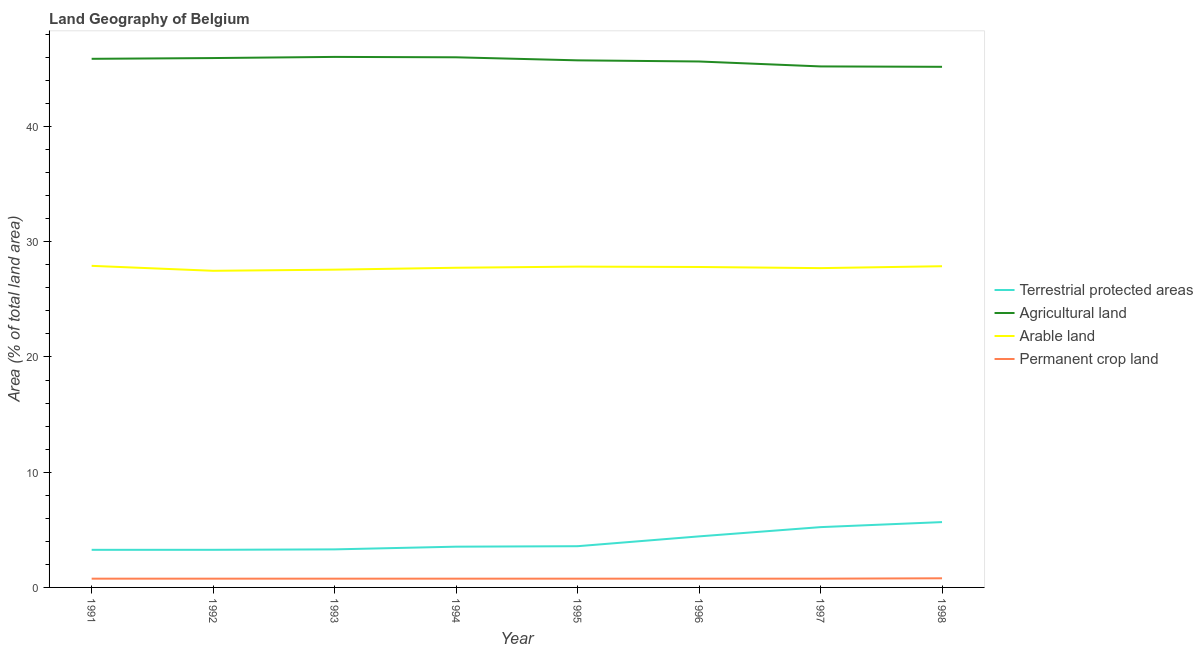How many different coloured lines are there?
Provide a succinct answer. 4. Does the line corresponding to percentage of land under terrestrial protection intersect with the line corresponding to percentage of area under arable land?
Make the answer very short. No. What is the percentage of land under terrestrial protection in 1993?
Your answer should be very brief. 3.3. Across all years, what is the maximum percentage of area under permanent crop land?
Provide a short and direct response. 0.79. Across all years, what is the minimum percentage of area under arable land?
Make the answer very short. 27.48. In which year was the percentage of area under arable land minimum?
Keep it short and to the point. 1992. What is the total percentage of area under arable land in the graph?
Keep it short and to the point. 221.93. What is the difference between the percentage of area under arable land in 1993 and that in 1994?
Offer a very short reply. -0.17. What is the difference between the percentage of area under agricultural land in 1996 and the percentage of land under terrestrial protection in 1995?
Give a very brief answer. 42.06. What is the average percentage of area under permanent crop land per year?
Offer a very short reply. 0.76. In the year 1993, what is the difference between the percentage of land under terrestrial protection and percentage of area under agricultural land?
Your answer should be compact. -42.74. In how many years, is the percentage of area under permanent crop land greater than 38 %?
Your answer should be very brief. 0. What is the ratio of the percentage of area under arable land in 1991 to that in 1994?
Offer a terse response. 1.01. Is the difference between the percentage of area under permanent crop land in 1992 and 1994 greater than the difference between the percentage of area under arable land in 1992 and 1994?
Keep it short and to the point. Yes. What is the difference between the highest and the second highest percentage of area under agricultural land?
Give a very brief answer. 0.03. What is the difference between the highest and the lowest percentage of area under arable land?
Ensure brevity in your answer.  0.43. Is the sum of the percentage of land under terrestrial protection in 1993 and 1997 greater than the maximum percentage of area under arable land across all years?
Provide a short and direct response. No. Is it the case that in every year, the sum of the percentage of area under agricultural land and percentage of area under permanent crop land is greater than the sum of percentage of land under terrestrial protection and percentage of area under arable land?
Offer a very short reply. No. Is it the case that in every year, the sum of the percentage of land under terrestrial protection and percentage of area under agricultural land is greater than the percentage of area under arable land?
Ensure brevity in your answer.  Yes. Is the percentage of land under terrestrial protection strictly less than the percentage of area under agricultural land over the years?
Your answer should be compact. Yes. What is the difference between two consecutive major ticks on the Y-axis?
Provide a short and direct response. 10. Are the values on the major ticks of Y-axis written in scientific E-notation?
Provide a short and direct response. No. Does the graph contain grids?
Your answer should be compact. No. Where does the legend appear in the graph?
Provide a short and direct response. Center right. How many legend labels are there?
Provide a short and direct response. 4. What is the title of the graph?
Make the answer very short. Land Geography of Belgium. Does "Australia" appear as one of the legend labels in the graph?
Offer a terse response. No. What is the label or title of the Y-axis?
Your answer should be compact. Area (% of total land area). What is the Area (% of total land area) of Terrestrial protected areas in 1991?
Offer a terse response. 3.26. What is the Area (% of total land area) of Agricultural land in 1991?
Offer a very short reply. 45.87. What is the Area (% of total land area) of Arable land in 1991?
Your response must be concise. 27.91. What is the Area (% of total land area) of Permanent crop land in 1991?
Offer a terse response. 0.76. What is the Area (% of total land area) in Terrestrial protected areas in 1992?
Give a very brief answer. 3.26. What is the Area (% of total land area) of Agricultural land in 1992?
Offer a very short reply. 45.94. What is the Area (% of total land area) of Arable land in 1992?
Ensure brevity in your answer.  27.48. What is the Area (% of total land area) of Permanent crop land in 1992?
Provide a short and direct response. 0.76. What is the Area (% of total land area) of Terrestrial protected areas in 1993?
Keep it short and to the point. 3.3. What is the Area (% of total land area) of Agricultural land in 1993?
Your answer should be compact. 46.04. What is the Area (% of total land area) in Arable land in 1993?
Keep it short and to the point. 27.58. What is the Area (% of total land area) of Permanent crop land in 1993?
Offer a terse response. 0.76. What is the Area (% of total land area) in Terrestrial protected areas in 1994?
Your response must be concise. 3.54. What is the Area (% of total land area) of Agricultural land in 1994?
Make the answer very short. 46. What is the Area (% of total land area) of Arable land in 1994?
Offer a very short reply. 27.74. What is the Area (% of total land area) of Permanent crop land in 1994?
Make the answer very short. 0.76. What is the Area (% of total land area) in Terrestrial protected areas in 1995?
Make the answer very short. 3.58. What is the Area (% of total land area) of Agricultural land in 1995?
Offer a very short reply. 45.74. What is the Area (% of total land area) in Arable land in 1995?
Your response must be concise. 27.84. What is the Area (% of total land area) of Permanent crop land in 1995?
Keep it short and to the point. 0.76. What is the Area (% of total land area) of Terrestrial protected areas in 1996?
Provide a succinct answer. 4.43. What is the Area (% of total land area) in Agricultural land in 1996?
Provide a short and direct response. 45.64. What is the Area (% of total land area) of Arable land in 1996?
Provide a short and direct response. 27.81. What is the Area (% of total land area) in Permanent crop land in 1996?
Your answer should be compact. 0.76. What is the Area (% of total land area) in Terrestrial protected areas in 1997?
Keep it short and to the point. 5.23. What is the Area (% of total land area) of Agricultural land in 1997?
Your response must be concise. 45.21. What is the Area (% of total land area) in Arable land in 1997?
Offer a very short reply. 27.71. What is the Area (% of total land area) in Permanent crop land in 1997?
Make the answer very short. 0.76. What is the Area (% of total land area) of Terrestrial protected areas in 1998?
Make the answer very short. 5.67. What is the Area (% of total land area) of Agricultural land in 1998?
Provide a succinct answer. 45.18. What is the Area (% of total land area) of Arable land in 1998?
Provide a succinct answer. 27.87. What is the Area (% of total land area) in Permanent crop land in 1998?
Keep it short and to the point. 0.79. Across all years, what is the maximum Area (% of total land area) in Terrestrial protected areas?
Give a very brief answer. 5.67. Across all years, what is the maximum Area (% of total land area) of Agricultural land?
Give a very brief answer. 46.04. Across all years, what is the maximum Area (% of total land area) of Arable land?
Make the answer very short. 27.91. Across all years, what is the maximum Area (% of total land area) of Permanent crop land?
Your answer should be very brief. 0.79. Across all years, what is the minimum Area (% of total land area) of Terrestrial protected areas?
Offer a terse response. 3.26. Across all years, what is the minimum Area (% of total land area) in Agricultural land?
Provide a succinct answer. 45.18. Across all years, what is the minimum Area (% of total land area) of Arable land?
Ensure brevity in your answer.  27.48. Across all years, what is the minimum Area (% of total land area) in Permanent crop land?
Your response must be concise. 0.76. What is the total Area (% of total land area) in Terrestrial protected areas in the graph?
Your response must be concise. 32.27. What is the total Area (% of total land area) in Agricultural land in the graph?
Your answer should be compact. 365.62. What is the total Area (% of total land area) of Arable land in the graph?
Offer a terse response. 221.93. What is the total Area (% of total land area) in Permanent crop land in the graph?
Ensure brevity in your answer.  6.11. What is the difference between the Area (% of total land area) in Terrestrial protected areas in 1991 and that in 1992?
Your answer should be very brief. -0. What is the difference between the Area (% of total land area) of Agricultural land in 1991 and that in 1992?
Provide a succinct answer. -0.07. What is the difference between the Area (% of total land area) of Arable land in 1991 and that in 1992?
Offer a terse response. 0.43. What is the difference between the Area (% of total land area) of Permanent crop land in 1991 and that in 1992?
Provide a succinct answer. 0. What is the difference between the Area (% of total land area) of Terrestrial protected areas in 1991 and that in 1993?
Ensure brevity in your answer.  -0.04. What is the difference between the Area (% of total land area) in Agricultural land in 1991 and that in 1993?
Your response must be concise. -0.17. What is the difference between the Area (% of total land area) of Arable land in 1991 and that in 1993?
Give a very brief answer. 0.33. What is the difference between the Area (% of total land area) of Terrestrial protected areas in 1991 and that in 1994?
Offer a very short reply. -0.27. What is the difference between the Area (% of total land area) of Agricultural land in 1991 and that in 1994?
Your answer should be compact. -0.13. What is the difference between the Area (% of total land area) in Arable land in 1991 and that in 1994?
Make the answer very short. 0.17. What is the difference between the Area (% of total land area) in Permanent crop land in 1991 and that in 1994?
Offer a very short reply. 0. What is the difference between the Area (% of total land area) of Terrestrial protected areas in 1991 and that in 1995?
Provide a succinct answer. -0.31. What is the difference between the Area (% of total land area) in Agricultural land in 1991 and that in 1995?
Your answer should be compact. 0.13. What is the difference between the Area (% of total land area) in Arable land in 1991 and that in 1995?
Ensure brevity in your answer.  0.07. What is the difference between the Area (% of total land area) of Permanent crop land in 1991 and that in 1995?
Keep it short and to the point. 0. What is the difference between the Area (% of total land area) of Terrestrial protected areas in 1991 and that in 1996?
Keep it short and to the point. -1.17. What is the difference between the Area (% of total land area) in Agricultural land in 1991 and that in 1996?
Ensure brevity in your answer.  0.23. What is the difference between the Area (% of total land area) in Arable land in 1991 and that in 1996?
Your answer should be very brief. 0.1. What is the difference between the Area (% of total land area) in Permanent crop land in 1991 and that in 1996?
Give a very brief answer. 0. What is the difference between the Area (% of total land area) of Terrestrial protected areas in 1991 and that in 1997?
Ensure brevity in your answer.  -1.97. What is the difference between the Area (% of total land area) of Agricultural land in 1991 and that in 1997?
Your answer should be compact. 0.66. What is the difference between the Area (% of total land area) of Arable land in 1991 and that in 1997?
Give a very brief answer. 0.2. What is the difference between the Area (% of total land area) in Terrestrial protected areas in 1991 and that in 1998?
Make the answer very short. -2.41. What is the difference between the Area (% of total land area) of Agricultural land in 1991 and that in 1998?
Provide a short and direct response. 0.69. What is the difference between the Area (% of total land area) of Arable land in 1991 and that in 1998?
Your answer should be compact. 0.03. What is the difference between the Area (% of total land area) in Permanent crop land in 1991 and that in 1998?
Give a very brief answer. -0.03. What is the difference between the Area (% of total land area) in Terrestrial protected areas in 1992 and that in 1993?
Keep it short and to the point. -0.04. What is the difference between the Area (% of total land area) in Agricultural land in 1992 and that in 1993?
Provide a succinct answer. -0.1. What is the difference between the Area (% of total land area) of Arable land in 1992 and that in 1993?
Your response must be concise. -0.1. What is the difference between the Area (% of total land area) of Terrestrial protected areas in 1992 and that in 1994?
Offer a terse response. -0.27. What is the difference between the Area (% of total land area) in Agricultural land in 1992 and that in 1994?
Offer a terse response. -0.07. What is the difference between the Area (% of total land area) of Arable land in 1992 and that in 1994?
Your answer should be very brief. -0.26. What is the difference between the Area (% of total land area) in Terrestrial protected areas in 1992 and that in 1995?
Provide a succinct answer. -0.31. What is the difference between the Area (% of total land area) of Agricultural land in 1992 and that in 1995?
Make the answer very short. 0.2. What is the difference between the Area (% of total land area) in Arable land in 1992 and that in 1995?
Your answer should be compact. -0.36. What is the difference between the Area (% of total land area) of Permanent crop land in 1992 and that in 1995?
Ensure brevity in your answer.  0. What is the difference between the Area (% of total land area) in Terrestrial protected areas in 1992 and that in 1996?
Make the answer very short. -1.17. What is the difference between the Area (% of total land area) of Agricultural land in 1992 and that in 1996?
Offer a very short reply. 0.3. What is the difference between the Area (% of total land area) in Arable land in 1992 and that in 1996?
Your answer should be very brief. -0.33. What is the difference between the Area (% of total land area) of Terrestrial protected areas in 1992 and that in 1997?
Provide a succinct answer. -1.97. What is the difference between the Area (% of total land area) in Agricultural land in 1992 and that in 1997?
Keep it short and to the point. 0.73. What is the difference between the Area (% of total land area) of Arable land in 1992 and that in 1997?
Your answer should be compact. -0.23. What is the difference between the Area (% of total land area) of Permanent crop land in 1992 and that in 1997?
Keep it short and to the point. 0. What is the difference between the Area (% of total land area) in Terrestrial protected areas in 1992 and that in 1998?
Your response must be concise. -2.41. What is the difference between the Area (% of total land area) of Agricultural land in 1992 and that in 1998?
Offer a very short reply. 0.76. What is the difference between the Area (% of total land area) of Arable land in 1992 and that in 1998?
Your response must be concise. -0.4. What is the difference between the Area (% of total land area) of Permanent crop land in 1992 and that in 1998?
Give a very brief answer. -0.03. What is the difference between the Area (% of total land area) of Terrestrial protected areas in 1993 and that in 1994?
Make the answer very short. -0.24. What is the difference between the Area (% of total land area) of Agricultural land in 1993 and that in 1994?
Your answer should be very brief. 0.03. What is the difference between the Area (% of total land area) in Arable land in 1993 and that in 1994?
Keep it short and to the point. -0.17. What is the difference between the Area (% of total land area) of Terrestrial protected areas in 1993 and that in 1995?
Keep it short and to the point. -0.28. What is the difference between the Area (% of total land area) in Agricultural land in 1993 and that in 1995?
Offer a terse response. 0.3. What is the difference between the Area (% of total land area) in Arable land in 1993 and that in 1995?
Give a very brief answer. -0.26. What is the difference between the Area (% of total land area) of Permanent crop land in 1993 and that in 1995?
Your answer should be very brief. 0. What is the difference between the Area (% of total land area) in Terrestrial protected areas in 1993 and that in 1996?
Offer a terse response. -1.13. What is the difference between the Area (% of total land area) in Agricultural land in 1993 and that in 1996?
Offer a very short reply. 0.4. What is the difference between the Area (% of total land area) in Arable land in 1993 and that in 1996?
Offer a terse response. -0.23. What is the difference between the Area (% of total land area) of Terrestrial protected areas in 1993 and that in 1997?
Your response must be concise. -1.93. What is the difference between the Area (% of total land area) in Agricultural land in 1993 and that in 1997?
Give a very brief answer. 0.83. What is the difference between the Area (% of total land area) in Arable land in 1993 and that in 1997?
Make the answer very short. -0.13. What is the difference between the Area (% of total land area) of Permanent crop land in 1993 and that in 1997?
Your response must be concise. 0. What is the difference between the Area (% of total land area) in Terrestrial protected areas in 1993 and that in 1998?
Your answer should be very brief. -2.37. What is the difference between the Area (% of total land area) in Agricultural land in 1993 and that in 1998?
Your answer should be compact. 0.86. What is the difference between the Area (% of total land area) in Arable land in 1993 and that in 1998?
Your answer should be compact. -0.3. What is the difference between the Area (% of total land area) in Permanent crop land in 1993 and that in 1998?
Provide a succinct answer. -0.03. What is the difference between the Area (% of total land area) of Terrestrial protected areas in 1994 and that in 1995?
Make the answer very short. -0.04. What is the difference between the Area (% of total land area) in Agricultural land in 1994 and that in 1995?
Offer a terse response. 0.26. What is the difference between the Area (% of total land area) of Arable land in 1994 and that in 1995?
Your answer should be compact. -0.1. What is the difference between the Area (% of total land area) in Permanent crop land in 1994 and that in 1995?
Provide a short and direct response. 0. What is the difference between the Area (% of total land area) of Terrestrial protected areas in 1994 and that in 1996?
Keep it short and to the point. -0.89. What is the difference between the Area (% of total land area) in Agricultural land in 1994 and that in 1996?
Keep it short and to the point. 0.36. What is the difference between the Area (% of total land area) of Arable land in 1994 and that in 1996?
Offer a very short reply. -0.07. What is the difference between the Area (% of total land area) of Permanent crop land in 1994 and that in 1996?
Provide a short and direct response. 0. What is the difference between the Area (% of total land area) of Terrestrial protected areas in 1994 and that in 1997?
Make the answer very short. -1.7. What is the difference between the Area (% of total land area) of Agricultural land in 1994 and that in 1997?
Provide a succinct answer. 0.79. What is the difference between the Area (% of total land area) of Arable land in 1994 and that in 1997?
Ensure brevity in your answer.  0.03. What is the difference between the Area (% of total land area) of Permanent crop land in 1994 and that in 1997?
Your response must be concise. 0. What is the difference between the Area (% of total land area) of Terrestrial protected areas in 1994 and that in 1998?
Ensure brevity in your answer.  -2.13. What is the difference between the Area (% of total land area) in Agricultural land in 1994 and that in 1998?
Ensure brevity in your answer.  0.83. What is the difference between the Area (% of total land area) in Arable land in 1994 and that in 1998?
Make the answer very short. -0.13. What is the difference between the Area (% of total land area) of Permanent crop land in 1994 and that in 1998?
Give a very brief answer. -0.03. What is the difference between the Area (% of total land area) of Terrestrial protected areas in 1995 and that in 1996?
Offer a terse response. -0.85. What is the difference between the Area (% of total land area) of Agricultural land in 1995 and that in 1996?
Provide a succinct answer. 0.1. What is the difference between the Area (% of total land area) of Arable land in 1995 and that in 1996?
Ensure brevity in your answer.  0.03. What is the difference between the Area (% of total land area) in Permanent crop land in 1995 and that in 1996?
Provide a succinct answer. 0. What is the difference between the Area (% of total land area) in Terrestrial protected areas in 1995 and that in 1997?
Your response must be concise. -1.66. What is the difference between the Area (% of total land area) in Agricultural land in 1995 and that in 1997?
Ensure brevity in your answer.  0.53. What is the difference between the Area (% of total land area) of Arable land in 1995 and that in 1997?
Make the answer very short. 0.13. What is the difference between the Area (% of total land area) in Permanent crop land in 1995 and that in 1997?
Ensure brevity in your answer.  0. What is the difference between the Area (% of total land area) in Terrestrial protected areas in 1995 and that in 1998?
Make the answer very short. -2.09. What is the difference between the Area (% of total land area) of Agricultural land in 1995 and that in 1998?
Offer a very short reply. 0.56. What is the difference between the Area (% of total land area) in Arable land in 1995 and that in 1998?
Your answer should be very brief. -0.03. What is the difference between the Area (% of total land area) of Permanent crop land in 1995 and that in 1998?
Your answer should be compact. -0.03. What is the difference between the Area (% of total land area) of Terrestrial protected areas in 1996 and that in 1997?
Offer a terse response. -0.8. What is the difference between the Area (% of total land area) of Agricultural land in 1996 and that in 1997?
Your answer should be compact. 0.43. What is the difference between the Area (% of total land area) in Arable land in 1996 and that in 1997?
Keep it short and to the point. 0.1. What is the difference between the Area (% of total land area) of Permanent crop land in 1996 and that in 1997?
Give a very brief answer. 0. What is the difference between the Area (% of total land area) of Terrestrial protected areas in 1996 and that in 1998?
Your response must be concise. -1.24. What is the difference between the Area (% of total land area) of Agricultural land in 1996 and that in 1998?
Your response must be concise. 0.46. What is the difference between the Area (% of total land area) of Arable land in 1996 and that in 1998?
Offer a very short reply. -0.07. What is the difference between the Area (% of total land area) in Permanent crop land in 1996 and that in 1998?
Offer a very short reply. -0.03. What is the difference between the Area (% of total land area) in Terrestrial protected areas in 1997 and that in 1998?
Your answer should be compact. -0.44. What is the difference between the Area (% of total land area) in Agricultural land in 1997 and that in 1998?
Your response must be concise. 0.03. What is the difference between the Area (% of total land area) of Arable land in 1997 and that in 1998?
Ensure brevity in your answer.  -0.17. What is the difference between the Area (% of total land area) in Permanent crop land in 1997 and that in 1998?
Your answer should be very brief. -0.03. What is the difference between the Area (% of total land area) of Terrestrial protected areas in 1991 and the Area (% of total land area) of Agricultural land in 1992?
Provide a succinct answer. -42.68. What is the difference between the Area (% of total land area) in Terrestrial protected areas in 1991 and the Area (% of total land area) in Arable land in 1992?
Your response must be concise. -24.21. What is the difference between the Area (% of total land area) of Terrestrial protected areas in 1991 and the Area (% of total land area) of Permanent crop land in 1992?
Your answer should be compact. 2.5. What is the difference between the Area (% of total land area) in Agricultural land in 1991 and the Area (% of total land area) in Arable land in 1992?
Provide a succinct answer. 18.39. What is the difference between the Area (% of total land area) in Agricultural land in 1991 and the Area (% of total land area) in Permanent crop land in 1992?
Keep it short and to the point. 45.11. What is the difference between the Area (% of total land area) of Arable land in 1991 and the Area (% of total land area) of Permanent crop land in 1992?
Your response must be concise. 27.15. What is the difference between the Area (% of total land area) in Terrestrial protected areas in 1991 and the Area (% of total land area) in Agricultural land in 1993?
Your answer should be very brief. -42.77. What is the difference between the Area (% of total land area) of Terrestrial protected areas in 1991 and the Area (% of total land area) of Arable land in 1993?
Make the answer very short. -24.31. What is the difference between the Area (% of total land area) of Terrestrial protected areas in 1991 and the Area (% of total land area) of Permanent crop land in 1993?
Provide a succinct answer. 2.5. What is the difference between the Area (% of total land area) in Agricultural land in 1991 and the Area (% of total land area) in Arable land in 1993?
Your response must be concise. 18.3. What is the difference between the Area (% of total land area) in Agricultural land in 1991 and the Area (% of total land area) in Permanent crop land in 1993?
Ensure brevity in your answer.  45.11. What is the difference between the Area (% of total land area) of Arable land in 1991 and the Area (% of total land area) of Permanent crop land in 1993?
Provide a short and direct response. 27.15. What is the difference between the Area (% of total land area) of Terrestrial protected areas in 1991 and the Area (% of total land area) of Agricultural land in 1994?
Provide a short and direct response. -42.74. What is the difference between the Area (% of total land area) in Terrestrial protected areas in 1991 and the Area (% of total land area) in Arable land in 1994?
Keep it short and to the point. -24.48. What is the difference between the Area (% of total land area) in Terrestrial protected areas in 1991 and the Area (% of total land area) in Permanent crop land in 1994?
Provide a short and direct response. 2.5. What is the difference between the Area (% of total land area) in Agricultural land in 1991 and the Area (% of total land area) in Arable land in 1994?
Your answer should be very brief. 18.13. What is the difference between the Area (% of total land area) in Agricultural land in 1991 and the Area (% of total land area) in Permanent crop land in 1994?
Offer a terse response. 45.11. What is the difference between the Area (% of total land area) in Arable land in 1991 and the Area (% of total land area) in Permanent crop land in 1994?
Provide a short and direct response. 27.15. What is the difference between the Area (% of total land area) in Terrestrial protected areas in 1991 and the Area (% of total land area) in Agricultural land in 1995?
Provide a succinct answer. -42.48. What is the difference between the Area (% of total land area) of Terrestrial protected areas in 1991 and the Area (% of total land area) of Arable land in 1995?
Offer a terse response. -24.58. What is the difference between the Area (% of total land area) of Terrestrial protected areas in 1991 and the Area (% of total land area) of Permanent crop land in 1995?
Your answer should be very brief. 2.5. What is the difference between the Area (% of total land area) in Agricultural land in 1991 and the Area (% of total land area) in Arable land in 1995?
Provide a short and direct response. 18.03. What is the difference between the Area (% of total land area) in Agricultural land in 1991 and the Area (% of total land area) in Permanent crop land in 1995?
Offer a terse response. 45.11. What is the difference between the Area (% of total land area) of Arable land in 1991 and the Area (% of total land area) of Permanent crop land in 1995?
Your response must be concise. 27.15. What is the difference between the Area (% of total land area) in Terrestrial protected areas in 1991 and the Area (% of total land area) in Agricultural land in 1996?
Keep it short and to the point. -42.38. What is the difference between the Area (% of total land area) of Terrestrial protected areas in 1991 and the Area (% of total land area) of Arable land in 1996?
Give a very brief answer. -24.54. What is the difference between the Area (% of total land area) in Terrestrial protected areas in 1991 and the Area (% of total land area) in Permanent crop land in 1996?
Offer a terse response. 2.5. What is the difference between the Area (% of total land area) in Agricultural land in 1991 and the Area (% of total land area) in Arable land in 1996?
Your answer should be very brief. 18.06. What is the difference between the Area (% of total land area) of Agricultural land in 1991 and the Area (% of total land area) of Permanent crop land in 1996?
Give a very brief answer. 45.11. What is the difference between the Area (% of total land area) of Arable land in 1991 and the Area (% of total land area) of Permanent crop land in 1996?
Your answer should be very brief. 27.15. What is the difference between the Area (% of total land area) of Terrestrial protected areas in 1991 and the Area (% of total land area) of Agricultural land in 1997?
Give a very brief answer. -41.95. What is the difference between the Area (% of total land area) in Terrestrial protected areas in 1991 and the Area (% of total land area) in Arable land in 1997?
Ensure brevity in your answer.  -24.45. What is the difference between the Area (% of total land area) in Terrestrial protected areas in 1991 and the Area (% of total land area) in Permanent crop land in 1997?
Keep it short and to the point. 2.5. What is the difference between the Area (% of total land area) of Agricultural land in 1991 and the Area (% of total land area) of Arable land in 1997?
Provide a succinct answer. 18.16. What is the difference between the Area (% of total land area) of Agricultural land in 1991 and the Area (% of total land area) of Permanent crop land in 1997?
Your answer should be very brief. 45.11. What is the difference between the Area (% of total land area) in Arable land in 1991 and the Area (% of total land area) in Permanent crop land in 1997?
Offer a very short reply. 27.15. What is the difference between the Area (% of total land area) in Terrestrial protected areas in 1991 and the Area (% of total land area) in Agricultural land in 1998?
Your answer should be very brief. -41.92. What is the difference between the Area (% of total land area) of Terrestrial protected areas in 1991 and the Area (% of total land area) of Arable land in 1998?
Keep it short and to the point. -24.61. What is the difference between the Area (% of total land area) of Terrestrial protected areas in 1991 and the Area (% of total land area) of Permanent crop land in 1998?
Your answer should be very brief. 2.47. What is the difference between the Area (% of total land area) of Agricultural land in 1991 and the Area (% of total land area) of Arable land in 1998?
Ensure brevity in your answer.  18. What is the difference between the Area (% of total land area) of Agricultural land in 1991 and the Area (% of total land area) of Permanent crop land in 1998?
Provide a short and direct response. 45.08. What is the difference between the Area (% of total land area) of Arable land in 1991 and the Area (% of total land area) of Permanent crop land in 1998?
Provide a short and direct response. 27.11. What is the difference between the Area (% of total land area) in Terrestrial protected areas in 1992 and the Area (% of total land area) in Agricultural land in 1993?
Your response must be concise. -42.77. What is the difference between the Area (% of total land area) in Terrestrial protected areas in 1992 and the Area (% of total land area) in Arable land in 1993?
Ensure brevity in your answer.  -24.31. What is the difference between the Area (% of total land area) of Terrestrial protected areas in 1992 and the Area (% of total land area) of Permanent crop land in 1993?
Offer a very short reply. 2.5. What is the difference between the Area (% of total land area) of Agricultural land in 1992 and the Area (% of total land area) of Arable land in 1993?
Ensure brevity in your answer.  18.36. What is the difference between the Area (% of total land area) in Agricultural land in 1992 and the Area (% of total land area) in Permanent crop land in 1993?
Give a very brief answer. 45.18. What is the difference between the Area (% of total land area) in Arable land in 1992 and the Area (% of total land area) in Permanent crop land in 1993?
Ensure brevity in your answer.  26.72. What is the difference between the Area (% of total land area) of Terrestrial protected areas in 1992 and the Area (% of total land area) of Agricultural land in 1994?
Provide a short and direct response. -42.74. What is the difference between the Area (% of total land area) in Terrestrial protected areas in 1992 and the Area (% of total land area) in Arable land in 1994?
Give a very brief answer. -24.48. What is the difference between the Area (% of total land area) in Terrestrial protected areas in 1992 and the Area (% of total land area) in Permanent crop land in 1994?
Your answer should be compact. 2.5. What is the difference between the Area (% of total land area) in Agricultural land in 1992 and the Area (% of total land area) in Arable land in 1994?
Your answer should be very brief. 18.2. What is the difference between the Area (% of total land area) in Agricultural land in 1992 and the Area (% of total land area) in Permanent crop land in 1994?
Provide a short and direct response. 45.18. What is the difference between the Area (% of total land area) in Arable land in 1992 and the Area (% of total land area) in Permanent crop land in 1994?
Keep it short and to the point. 26.72. What is the difference between the Area (% of total land area) in Terrestrial protected areas in 1992 and the Area (% of total land area) in Agricultural land in 1995?
Ensure brevity in your answer.  -42.48. What is the difference between the Area (% of total land area) in Terrestrial protected areas in 1992 and the Area (% of total land area) in Arable land in 1995?
Offer a terse response. -24.58. What is the difference between the Area (% of total land area) in Terrestrial protected areas in 1992 and the Area (% of total land area) in Permanent crop land in 1995?
Ensure brevity in your answer.  2.5. What is the difference between the Area (% of total land area) of Agricultural land in 1992 and the Area (% of total land area) of Arable land in 1995?
Offer a terse response. 18.1. What is the difference between the Area (% of total land area) in Agricultural land in 1992 and the Area (% of total land area) in Permanent crop land in 1995?
Make the answer very short. 45.18. What is the difference between the Area (% of total land area) of Arable land in 1992 and the Area (% of total land area) of Permanent crop land in 1995?
Provide a short and direct response. 26.72. What is the difference between the Area (% of total land area) in Terrestrial protected areas in 1992 and the Area (% of total land area) in Agricultural land in 1996?
Provide a short and direct response. -42.38. What is the difference between the Area (% of total land area) of Terrestrial protected areas in 1992 and the Area (% of total land area) of Arable land in 1996?
Provide a succinct answer. -24.54. What is the difference between the Area (% of total land area) of Terrestrial protected areas in 1992 and the Area (% of total land area) of Permanent crop land in 1996?
Your answer should be compact. 2.5. What is the difference between the Area (% of total land area) of Agricultural land in 1992 and the Area (% of total land area) of Arable land in 1996?
Provide a succinct answer. 18.13. What is the difference between the Area (% of total land area) in Agricultural land in 1992 and the Area (% of total land area) in Permanent crop land in 1996?
Provide a succinct answer. 45.18. What is the difference between the Area (% of total land area) of Arable land in 1992 and the Area (% of total land area) of Permanent crop land in 1996?
Your response must be concise. 26.72. What is the difference between the Area (% of total land area) in Terrestrial protected areas in 1992 and the Area (% of total land area) in Agricultural land in 1997?
Give a very brief answer. -41.95. What is the difference between the Area (% of total land area) of Terrestrial protected areas in 1992 and the Area (% of total land area) of Arable land in 1997?
Offer a terse response. -24.44. What is the difference between the Area (% of total land area) of Terrestrial protected areas in 1992 and the Area (% of total land area) of Permanent crop land in 1997?
Offer a very short reply. 2.5. What is the difference between the Area (% of total land area) of Agricultural land in 1992 and the Area (% of total land area) of Arable land in 1997?
Make the answer very short. 18.23. What is the difference between the Area (% of total land area) of Agricultural land in 1992 and the Area (% of total land area) of Permanent crop land in 1997?
Offer a terse response. 45.18. What is the difference between the Area (% of total land area) in Arable land in 1992 and the Area (% of total land area) in Permanent crop land in 1997?
Make the answer very short. 26.72. What is the difference between the Area (% of total land area) in Terrestrial protected areas in 1992 and the Area (% of total land area) in Agricultural land in 1998?
Your answer should be very brief. -41.91. What is the difference between the Area (% of total land area) in Terrestrial protected areas in 1992 and the Area (% of total land area) in Arable land in 1998?
Make the answer very short. -24.61. What is the difference between the Area (% of total land area) in Terrestrial protected areas in 1992 and the Area (% of total land area) in Permanent crop land in 1998?
Offer a very short reply. 2.47. What is the difference between the Area (% of total land area) in Agricultural land in 1992 and the Area (% of total land area) in Arable land in 1998?
Your response must be concise. 18.06. What is the difference between the Area (% of total land area) of Agricultural land in 1992 and the Area (% of total land area) of Permanent crop land in 1998?
Make the answer very short. 45.15. What is the difference between the Area (% of total land area) in Arable land in 1992 and the Area (% of total land area) in Permanent crop land in 1998?
Make the answer very short. 26.68. What is the difference between the Area (% of total land area) of Terrestrial protected areas in 1993 and the Area (% of total land area) of Agricultural land in 1994?
Give a very brief answer. -42.7. What is the difference between the Area (% of total land area) of Terrestrial protected areas in 1993 and the Area (% of total land area) of Arable land in 1994?
Your answer should be very brief. -24.44. What is the difference between the Area (% of total land area) in Terrestrial protected areas in 1993 and the Area (% of total land area) in Permanent crop land in 1994?
Make the answer very short. 2.54. What is the difference between the Area (% of total land area) of Agricultural land in 1993 and the Area (% of total land area) of Arable land in 1994?
Make the answer very short. 18.3. What is the difference between the Area (% of total land area) in Agricultural land in 1993 and the Area (% of total land area) in Permanent crop land in 1994?
Offer a terse response. 45.28. What is the difference between the Area (% of total land area) in Arable land in 1993 and the Area (% of total land area) in Permanent crop land in 1994?
Provide a succinct answer. 26.82. What is the difference between the Area (% of total land area) in Terrestrial protected areas in 1993 and the Area (% of total land area) in Agricultural land in 1995?
Give a very brief answer. -42.44. What is the difference between the Area (% of total land area) in Terrestrial protected areas in 1993 and the Area (% of total land area) in Arable land in 1995?
Provide a short and direct response. -24.54. What is the difference between the Area (% of total land area) of Terrestrial protected areas in 1993 and the Area (% of total land area) of Permanent crop land in 1995?
Your response must be concise. 2.54. What is the difference between the Area (% of total land area) of Agricultural land in 1993 and the Area (% of total land area) of Arable land in 1995?
Your response must be concise. 18.2. What is the difference between the Area (% of total land area) in Agricultural land in 1993 and the Area (% of total land area) in Permanent crop land in 1995?
Your answer should be compact. 45.28. What is the difference between the Area (% of total land area) of Arable land in 1993 and the Area (% of total land area) of Permanent crop land in 1995?
Your answer should be very brief. 26.82. What is the difference between the Area (% of total land area) in Terrestrial protected areas in 1993 and the Area (% of total land area) in Agricultural land in 1996?
Keep it short and to the point. -42.34. What is the difference between the Area (% of total land area) in Terrestrial protected areas in 1993 and the Area (% of total land area) in Arable land in 1996?
Provide a short and direct response. -24.51. What is the difference between the Area (% of total land area) in Terrestrial protected areas in 1993 and the Area (% of total land area) in Permanent crop land in 1996?
Keep it short and to the point. 2.54. What is the difference between the Area (% of total land area) in Agricultural land in 1993 and the Area (% of total land area) in Arable land in 1996?
Your answer should be very brief. 18.23. What is the difference between the Area (% of total land area) in Agricultural land in 1993 and the Area (% of total land area) in Permanent crop land in 1996?
Your answer should be very brief. 45.28. What is the difference between the Area (% of total land area) in Arable land in 1993 and the Area (% of total land area) in Permanent crop land in 1996?
Give a very brief answer. 26.82. What is the difference between the Area (% of total land area) of Terrestrial protected areas in 1993 and the Area (% of total land area) of Agricultural land in 1997?
Ensure brevity in your answer.  -41.91. What is the difference between the Area (% of total land area) of Terrestrial protected areas in 1993 and the Area (% of total land area) of Arable land in 1997?
Provide a short and direct response. -24.41. What is the difference between the Area (% of total land area) in Terrestrial protected areas in 1993 and the Area (% of total land area) in Permanent crop land in 1997?
Ensure brevity in your answer.  2.54. What is the difference between the Area (% of total land area) of Agricultural land in 1993 and the Area (% of total land area) of Arable land in 1997?
Keep it short and to the point. 18.33. What is the difference between the Area (% of total land area) in Agricultural land in 1993 and the Area (% of total land area) in Permanent crop land in 1997?
Your answer should be very brief. 45.28. What is the difference between the Area (% of total land area) of Arable land in 1993 and the Area (% of total land area) of Permanent crop land in 1997?
Offer a very short reply. 26.82. What is the difference between the Area (% of total land area) in Terrestrial protected areas in 1993 and the Area (% of total land area) in Agricultural land in 1998?
Keep it short and to the point. -41.88. What is the difference between the Area (% of total land area) of Terrestrial protected areas in 1993 and the Area (% of total land area) of Arable land in 1998?
Offer a terse response. -24.57. What is the difference between the Area (% of total land area) in Terrestrial protected areas in 1993 and the Area (% of total land area) in Permanent crop land in 1998?
Provide a succinct answer. 2.51. What is the difference between the Area (% of total land area) of Agricultural land in 1993 and the Area (% of total land area) of Arable land in 1998?
Your response must be concise. 18.16. What is the difference between the Area (% of total land area) of Agricultural land in 1993 and the Area (% of total land area) of Permanent crop land in 1998?
Provide a short and direct response. 45.24. What is the difference between the Area (% of total land area) in Arable land in 1993 and the Area (% of total land area) in Permanent crop land in 1998?
Your answer should be very brief. 26.78. What is the difference between the Area (% of total land area) in Terrestrial protected areas in 1994 and the Area (% of total land area) in Agricultural land in 1995?
Provide a short and direct response. -42.2. What is the difference between the Area (% of total land area) in Terrestrial protected areas in 1994 and the Area (% of total land area) in Arable land in 1995?
Give a very brief answer. -24.3. What is the difference between the Area (% of total land area) in Terrestrial protected areas in 1994 and the Area (% of total land area) in Permanent crop land in 1995?
Ensure brevity in your answer.  2.78. What is the difference between the Area (% of total land area) in Agricultural land in 1994 and the Area (% of total land area) in Arable land in 1995?
Your answer should be compact. 18.16. What is the difference between the Area (% of total land area) of Agricultural land in 1994 and the Area (% of total land area) of Permanent crop land in 1995?
Provide a short and direct response. 45.24. What is the difference between the Area (% of total land area) in Arable land in 1994 and the Area (% of total land area) in Permanent crop land in 1995?
Keep it short and to the point. 26.98. What is the difference between the Area (% of total land area) in Terrestrial protected areas in 1994 and the Area (% of total land area) in Agricultural land in 1996?
Keep it short and to the point. -42.1. What is the difference between the Area (% of total land area) in Terrestrial protected areas in 1994 and the Area (% of total land area) in Arable land in 1996?
Your response must be concise. -24.27. What is the difference between the Area (% of total land area) of Terrestrial protected areas in 1994 and the Area (% of total land area) of Permanent crop land in 1996?
Keep it short and to the point. 2.78. What is the difference between the Area (% of total land area) in Agricultural land in 1994 and the Area (% of total land area) in Arable land in 1996?
Your answer should be very brief. 18.2. What is the difference between the Area (% of total land area) in Agricultural land in 1994 and the Area (% of total land area) in Permanent crop land in 1996?
Provide a succinct answer. 45.24. What is the difference between the Area (% of total land area) of Arable land in 1994 and the Area (% of total land area) of Permanent crop land in 1996?
Give a very brief answer. 26.98. What is the difference between the Area (% of total land area) of Terrestrial protected areas in 1994 and the Area (% of total land area) of Agricultural land in 1997?
Ensure brevity in your answer.  -41.67. What is the difference between the Area (% of total land area) in Terrestrial protected areas in 1994 and the Area (% of total land area) in Arable land in 1997?
Offer a terse response. -24.17. What is the difference between the Area (% of total land area) in Terrestrial protected areas in 1994 and the Area (% of total land area) in Permanent crop land in 1997?
Offer a very short reply. 2.78. What is the difference between the Area (% of total land area) in Agricultural land in 1994 and the Area (% of total land area) in Arable land in 1997?
Ensure brevity in your answer.  18.3. What is the difference between the Area (% of total land area) of Agricultural land in 1994 and the Area (% of total land area) of Permanent crop land in 1997?
Offer a terse response. 45.24. What is the difference between the Area (% of total land area) of Arable land in 1994 and the Area (% of total land area) of Permanent crop land in 1997?
Offer a very short reply. 26.98. What is the difference between the Area (% of total land area) in Terrestrial protected areas in 1994 and the Area (% of total land area) in Agricultural land in 1998?
Offer a terse response. -41.64. What is the difference between the Area (% of total land area) of Terrestrial protected areas in 1994 and the Area (% of total land area) of Arable land in 1998?
Your answer should be very brief. -24.34. What is the difference between the Area (% of total land area) of Terrestrial protected areas in 1994 and the Area (% of total land area) of Permanent crop land in 1998?
Your answer should be very brief. 2.74. What is the difference between the Area (% of total land area) of Agricultural land in 1994 and the Area (% of total land area) of Arable land in 1998?
Make the answer very short. 18.13. What is the difference between the Area (% of total land area) in Agricultural land in 1994 and the Area (% of total land area) in Permanent crop land in 1998?
Offer a terse response. 45.21. What is the difference between the Area (% of total land area) in Arable land in 1994 and the Area (% of total land area) in Permanent crop land in 1998?
Your answer should be compact. 26.95. What is the difference between the Area (% of total land area) of Terrestrial protected areas in 1995 and the Area (% of total land area) of Agricultural land in 1996?
Your response must be concise. -42.06. What is the difference between the Area (% of total land area) in Terrestrial protected areas in 1995 and the Area (% of total land area) in Arable land in 1996?
Make the answer very short. -24.23. What is the difference between the Area (% of total land area) of Terrestrial protected areas in 1995 and the Area (% of total land area) of Permanent crop land in 1996?
Offer a very short reply. 2.82. What is the difference between the Area (% of total land area) of Agricultural land in 1995 and the Area (% of total land area) of Arable land in 1996?
Give a very brief answer. 17.93. What is the difference between the Area (% of total land area) in Agricultural land in 1995 and the Area (% of total land area) in Permanent crop land in 1996?
Your response must be concise. 44.98. What is the difference between the Area (% of total land area) in Arable land in 1995 and the Area (% of total land area) in Permanent crop land in 1996?
Offer a terse response. 27.08. What is the difference between the Area (% of total land area) of Terrestrial protected areas in 1995 and the Area (% of total land area) of Agricultural land in 1997?
Your response must be concise. -41.63. What is the difference between the Area (% of total land area) in Terrestrial protected areas in 1995 and the Area (% of total land area) in Arable land in 1997?
Give a very brief answer. -24.13. What is the difference between the Area (% of total land area) of Terrestrial protected areas in 1995 and the Area (% of total land area) of Permanent crop land in 1997?
Ensure brevity in your answer.  2.82. What is the difference between the Area (% of total land area) of Agricultural land in 1995 and the Area (% of total land area) of Arable land in 1997?
Keep it short and to the point. 18.03. What is the difference between the Area (% of total land area) of Agricultural land in 1995 and the Area (% of total land area) of Permanent crop land in 1997?
Your answer should be compact. 44.98. What is the difference between the Area (% of total land area) in Arable land in 1995 and the Area (% of total land area) in Permanent crop land in 1997?
Make the answer very short. 27.08. What is the difference between the Area (% of total land area) of Terrestrial protected areas in 1995 and the Area (% of total land area) of Agricultural land in 1998?
Keep it short and to the point. -41.6. What is the difference between the Area (% of total land area) of Terrestrial protected areas in 1995 and the Area (% of total land area) of Arable land in 1998?
Offer a very short reply. -24.3. What is the difference between the Area (% of total land area) of Terrestrial protected areas in 1995 and the Area (% of total land area) of Permanent crop land in 1998?
Ensure brevity in your answer.  2.78. What is the difference between the Area (% of total land area) of Agricultural land in 1995 and the Area (% of total land area) of Arable land in 1998?
Make the answer very short. 17.87. What is the difference between the Area (% of total land area) in Agricultural land in 1995 and the Area (% of total land area) in Permanent crop land in 1998?
Your answer should be compact. 44.95. What is the difference between the Area (% of total land area) in Arable land in 1995 and the Area (% of total land area) in Permanent crop land in 1998?
Make the answer very short. 27.05. What is the difference between the Area (% of total land area) of Terrestrial protected areas in 1996 and the Area (% of total land area) of Agricultural land in 1997?
Give a very brief answer. -40.78. What is the difference between the Area (% of total land area) of Terrestrial protected areas in 1996 and the Area (% of total land area) of Arable land in 1997?
Provide a succinct answer. -23.28. What is the difference between the Area (% of total land area) in Terrestrial protected areas in 1996 and the Area (% of total land area) in Permanent crop land in 1997?
Offer a very short reply. 3.67. What is the difference between the Area (% of total land area) of Agricultural land in 1996 and the Area (% of total land area) of Arable land in 1997?
Offer a very short reply. 17.93. What is the difference between the Area (% of total land area) in Agricultural land in 1996 and the Area (% of total land area) in Permanent crop land in 1997?
Offer a very short reply. 44.88. What is the difference between the Area (% of total land area) in Arable land in 1996 and the Area (% of total land area) in Permanent crop land in 1997?
Your response must be concise. 27.05. What is the difference between the Area (% of total land area) of Terrestrial protected areas in 1996 and the Area (% of total land area) of Agricultural land in 1998?
Keep it short and to the point. -40.75. What is the difference between the Area (% of total land area) of Terrestrial protected areas in 1996 and the Area (% of total land area) of Arable land in 1998?
Provide a short and direct response. -23.44. What is the difference between the Area (% of total land area) in Terrestrial protected areas in 1996 and the Area (% of total land area) in Permanent crop land in 1998?
Ensure brevity in your answer.  3.64. What is the difference between the Area (% of total land area) in Agricultural land in 1996 and the Area (% of total land area) in Arable land in 1998?
Provide a short and direct response. 17.77. What is the difference between the Area (% of total land area) in Agricultural land in 1996 and the Area (% of total land area) in Permanent crop land in 1998?
Keep it short and to the point. 44.85. What is the difference between the Area (% of total land area) in Arable land in 1996 and the Area (% of total land area) in Permanent crop land in 1998?
Make the answer very short. 27.01. What is the difference between the Area (% of total land area) in Terrestrial protected areas in 1997 and the Area (% of total land area) in Agricultural land in 1998?
Offer a very short reply. -39.95. What is the difference between the Area (% of total land area) of Terrestrial protected areas in 1997 and the Area (% of total land area) of Arable land in 1998?
Your answer should be very brief. -22.64. What is the difference between the Area (% of total land area) in Terrestrial protected areas in 1997 and the Area (% of total land area) in Permanent crop land in 1998?
Offer a very short reply. 4.44. What is the difference between the Area (% of total land area) of Agricultural land in 1997 and the Area (% of total land area) of Arable land in 1998?
Make the answer very short. 17.34. What is the difference between the Area (% of total land area) in Agricultural land in 1997 and the Area (% of total land area) in Permanent crop land in 1998?
Offer a terse response. 44.42. What is the difference between the Area (% of total land area) of Arable land in 1997 and the Area (% of total land area) of Permanent crop land in 1998?
Offer a very short reply. 26.92. What is the average Area (% of total land area) of Terrestrial protected areas per year?
Your answer should be very brief. 4.03. What is the average Area (% of total land area) in Agricultural land per year?
Ensure brevity in your answer.  45.7. What is the average Area (% of total land area) in Arable land per year?
Your response must be concise. 27.74. What is the average Area (% of total land area) in Permanent crop land per year?
Your answer should be compact. 0.76. In the year 1991, what is the difference between the Area (% of total land area) in Terrestrial protected areas and Area (% of total land area) in Agricultural land?
Provide a succinct answer. -42.61. In the year 1991, what is the difference between the Area (% of total land area) of Terrestrial protected areas and Area (% of total land area) of Arable land?
Give a very brief answer. -24.64. In the year 1991, what is the difference between the Area (% of total land area) in Terrestrial protected areas and Area (% of total land area) in Permanent crop land?
Keep it short and to the point. 2.5. In the year 1991, what is the difference between the Area (% of total land area) of Agricultural land and Area (% of total land area) of Arable land?
Offer a terse response. 17.97. In the year 1991, what is the difference between the Area (% of total land area) of Agricultural land and Area (% of total land area) of Permanent crop land?
Provide a succinct answer. 45.11. In the year 1991, what is the difference between the Area (% of total land area) of Arable land and Area (% of total land area) of Permanent crop land?
Offer a very short reply. 27.15. In the year 1992, what is the difference between the Area (% of total land area) in Terrestrial protected areas and Area (% of total land area) in Agricultural land?
Ensure brevity in your answer.  -42.67. In the year 1992, what is the difference between the Area (% of total land area) in Terrestrial protected areas and Area (% of total land area) in Arable land?
Give a very brief answer. -24.21. In the year 1992, what is the difference between the Area (% of total land area) in Terrestrial protected areas and Area (% of total land area) in Permanent crop land?
Keep it short and to the point. 2.5. In the year 1992, what is the difference between the Area (% of total land area) of Agricultural land and Area (% of total land area) of Arable land?
Make the answer very short. 18.46. In the year 1992, what is the difference between the Area (% of total land area) in Agricultural land and Area (% of total land area) in Permanent crop land?
Your answer should be compact. 45.18. In the year 1992, what is the difference between the Area (% of total land area) in Arable land and Area (% of total land area) in Permanent crop land?
Keep it short and to the point. 26.72. In the year 1993, what is the difference between the Area (% of total land area) in Terrestrial protected areas and Area (% of total land area) in Agricultural land?
Provide a succinct answer. -42.74. In the year 1993, what is the difference between the Area (% of total land area) in Terrestrial protected areas and Area (% of total land area) in Arable land?
Your answer should be very brief. -24.27. In the year 1993, what is the difference between the Area (% of total land area) of Terrestrial protected areas and Area (% of total land area) of Permanent crop land?
Provide a short and direct response. 2.54. In the year 1993, what is the difference between the Area (% of total land area) of Agricultural land and Area (% of total land area) of Arable land?
Your response must be concise. 18.46. In the year 1993, what is the difference between the Area (% of total land area) of Agricultural land and Area (% of total land area) of Permanent crop land?
Ensure brevity in your answer.  45.28. In the year 1993, what is the difference between the Area (% of total land area) in Arable land and Area (% of total land area) in Permanent crop land?
Offer a terse response. 26.82. In the year 1994, what is the difference between the Area (% of total land area) of Terrestrial protected areas and Area (% of total land area) of Agricultural land?
Your answer should be compact. -42.47. In the year 1994, what is the difference between the Area (% of total land area) of Terrestrial protected areas and Area (% of total land area) of Arable land?
Offer a terse response. -24.2. In the year 1994, what is the difference between the Area (% of total land area) of Terrestrial protected areas and Area (% of total land area) of Permanent crop land?
Your answer should be very brief. 2.78. In the year 1994, what is the difference between the Area (% of total land area) in Agricultural land and Area (% of total land area) in Arable land?
Offer a terse response. 18.26. In the year 1994, what is the difference between the Area (% of total land area) of Agricultural land and Area (% of total land area) of Permanent crop land?
Your answer should be very brief. 45.24. In the year 1994, what is the difference between the Area (% of total land area) of Arable land and Area (% of total land area) of Permanent crop land?
Your answer should be very brief. 26.98. In the year 1995, what is the difference between the Area (% of total land area) of Terrestrial protected areas and Area (% of total land area) of Agricultural land?
Provide a succinct answer. -42.16. In the year 1995, what is the difference between the Area (% of total land area) of Terrestrial protected areas and Area (% of total land area) of Arable land?
Offer a very short reply. -24.26. In the year 1995, what is the difference between the Area (% of total land area) of Terrestrial protected areas and Area (% of total land area) of Permanent crop land?
Provide a succinct answer. 2.82. In the year 1995, what is the difference between the Area (% of total land area) in Agricultural land and Area (% of total land area) in Arable land?
Your answer should be very brief. 17.9. In the year 1995, what is the difference between the Area (% of total land area) of Agricultural land and Area (% of total land area) of Permanent crop land?
Your answer should be very brief. 44.98. In the year 1995, what is the difference between the Area (% of total land area) in Arable land and Area (% of total land area) in Permanent crop land?
Your answer should be very brief. 27.08. In the year 1996, what is the difference between the Area (% of total land area) in Terrestrial protected areas and Area (% of total land area) in Agricultural land?
Provide a short and direct response. -41.21. In the year 1996, what is the difference between the Area (% of total land area) of Terrestrial protected areas and Area (% of total land area) of Arable land?
Provide a short and direct response. -23.38. In the year 1996, what is the difference between the Area (% of total land area) in Terrestrial protected areas and Area (% of total land area) in Permanent crop land?
Provide a succinct answer. 3.67. In the year 1996, what is the difference between the Area (% of total land area) of Agricultural land and Area (% of total land area) of Arable land?
Make the answer very short. 17.83. In the year 1996, what is the difference between the Area (% of total land area) of Agricultural land and Area (% of total land area) of Permanent crop land?
Keep it short and to the point. 44.88. In the year 1996, what is the difference between the Area (% of total land area) of Arable land and Area (% of total land area) of Permanent crop land?
Offer a very short reply. 27.05. In the year 1997, what is the difference between the Area (% of total land area) in Terrestrial protected areas and Area (% of total land area) in Agricultural land?
Your answer should be very brief. -39.98. In the year 1997, what is the difference between the Area (% of total land area) of Terrestrial protected areas and Area (% of total land area) of Arable land?
Give a very brief answer. -22.47. In the year 1997, what is the difference between the Area (% of total land area) in Terrestrial protected areas and Area (% of total land area) in Permanent crop land?
Give a very brief answer. 4.47. In the year 1997, what is the difference between the Area (% of total land area) in Agricultural land and Area (% of total land area) in Arable land?
Your answer should be compact. 17.5. In the year 1997, what is the difference between the Area (% of total land area) in Agricultural land and Area (% of total land area) in Permanent crop land?
Ensure brevity in your answer.  44.45. In the year 1997, what is the difference between the Area (% of total land area) of Arable land and Area (% of total land area) of Permanent crop land?
Offer a terse response. 26.95. In the year 1998, what is the difference between the Area (% of total land area) of Terrestrial protected areas and Area (% of total land area) of Agricultural land?
Ensure brevity in your answer.  -39.51. In the year 1998, what is the difference between the Area (% of total land area) in Terrestrial protected areas and Area (% of total land area) in Arable land?
Ensure brevity in your answer.  -22.2. In the year 1998, what is the difference between the Area (% of total land area) in Terrestrial protected areas and Area (% of total land area) in Permanent crop land?
Give a very brief answer. 4.88. In the year 1998, what is the difference between the Area (% of total land area) of Agricultural land and Area (% of total land area) of Arable land?
Your response must be concise. 17.31. In the year 1998, what is the difference between the Area (% of total land area) in Agricultural land and Area (% of total land area) in Permanent crop land?
Offer a terse response. 44.39. In the year 1998, what is the difference between the Area (% of total land area) of Arable land and Area (% of total land area) of Permanent crop land?
Your response must be concise. 27.08. What is the ratio of the Area (% of total land area) in Terrestrial protected areas in 1991 to that in 1992?
Give a very brief answer. 1. What is the ratio of the Area (% of total land area) of Arable land in 1991 to that in 1992?
Keep it short and to the point. 1.02. What is the ratio of the Area (% of total land area) in Terrestrial protected areas in 1991 to that in 1993?
Offer a very short reply. 0.99. What is the ratio of the Area (% of total land area) of Agricultural land in 1991 to that in 1993?
Offer a very short reply. 1. What is the ratio of the Area (% of total land area) of Terrestrial protected areas in 1991 to that in 1994?
Make the answer very short. 0.92. What is the ratio of the Area (% of total land area) in Agricultural land in 1991 to that in 1994?
Make the answer very short. 1. What is the ratio of the Area (% of total land area) of Arable land in 1991 to that in 1994?
Provide a succinct answer. 1.01. What is the ratio of the Area (% of total land area) of Terrestrial protected areas in 1991 to that in 1995?
Give a very brief answer. 0.91. What is the ratio of the Area (% of total land area) in Terrestrial protected areas in 1991 to that in 1996?
Provide a short and direct response. 0.74. What is the ratio of the Area (% of total land area) in Agricultural land in 1991 to that in 1996?
Give a very brief answer. 1.01. What is the ratio of the Area (% of total land area) in Terrestrial protected areas in 1991 to that in 1997?
Make the answer very short. 0.62. What is the ratio of the Area (% of total land area) in Agricultural land in 1991 to that in 1997?
Ensure brevity in your answer.  1.01. What is the ratio of the Area (% of total land area) in Arable land in 1991 to that in 1997?
Your answer should be very brief. 1.01. What is the ratio of the Area (% of total land area) of Terrestrial protected areas in 1991 to that in 1998?
Your answer should be compact. 0.58. What is the ratio of the Area (% of total land area) in Agricultural land in 1991 to that in 1998?
Keep it short and to the point. 1.02. What is the ratio of the Area (% of total land area) of Terrestrial protected areas in 1992 to that in 1993?
Give a very brief answer. 0.99. What is the ratio of the Area (% of total land area) in Arable land in 1992 to that in 1993?
Provide a succinct answer. 1. What is the ratio of the Area (% of total land area) of Permanent crop land in 1992 to that in 1993?
Give a very brief answer. 1. What is the ratio of the Area (% of total land area) in Terrestrial protected areas in 1992 to that in 1994?
Your answer should be compact. 0.92. What is the ratio of the Area (% of total land area) in Agricultural land in 1992 to that in 1994?
Provide a succinct answer. 1. What is the ratio of the Area (% of total land area) of Terrestrial protected areas in 1992 to that in 1995?
Offer a terse response. 0.91. What is the ratio of the Area (% of total land area) in Agricultural land in 1992 to that in 1995?
Make the answer very short. 1. What is the ratio of the Area (% of total land area) of Permanent crop land in 1992 to that in 1995?
Offer a terse response. 1. What is the ratio of the Area (% of total land area) in Terrestrial protected areas in 1992 to that in 1996?
Offer a terse response. 0.74. What is the ratio of the Area (% of total land area) of Terrestrial protected areas in 1992 to that in 1997?
Offer a very short reply. 0.62. What is the ratio of the Area (% of total land area) of Agricultural land in 1992 to that in 1997?
Make the answer very short. 1.02. What is the ratio of the Area (% of total land area) in Terrestrial protected areas in 1992 to that in 1998?
Your answer should be compact. 0.58. What is the ratio of the Area (% of total land area) of Agricultural land in 1992 to that in 1998?
Your answer should be very brief. 1.02. What is the ratio of the Area (% of total land area) in Arable land in 1992 to that in 1998?
Provide a short and direct response. 0.99. What is the ratio of the Area (% of total land area) of Terrestrial protected areas in 1993 to that in 1994?
Make the answer very short. 0.93. What is the ratio of the Area (% of total land area) of Arable land in 1993 to that in 1994?
Make the answer very short. 0.99. What is the ratio of the Area (% of total land area) of Terrestrial protected areas in 1993 to that in 1995?
Give a very brief answer. 0.92. What is the ratio of the Area (% of total land area) of Permanent crop land in 1993 to that in 1995?
Keep it short and to the point. 1. What is the ratio of the Area (% of total land area) of Terrestrial protected areas in 1993 to that in 1996?
Offer a terse response. 0.75. What is the ratio of the Area (% of total land area) of Agricultural land in 1993 to that in 1996?
Give a very brief answer. 1.01. What is the ratio of the Area (% of total land area) in Permanent crop land in 1993 to that in 1996?
Your answer should be compact. 1. What is the ratio of the Area (% of total land area) of Terrestrial protected areas in 1993 to that in 1997?
Your answer should be compact. 0.63. What is the ratio of the Area (% of total land area) in Agricultural land in 1993 to that in 1997?
Make the answer very short. 1.02. What is the ratio of the Area (% of total land area) in Arable land in 1993 to that in 1997?
Offer a terse response. 1. What is the ratio of the Area (% of total land area) in Terrestrial protected areas in 1993 to that in 1998?
Your answer should be compact. 0.58. What is the ratio of the Area (% of total land area) in Agricultural land in 1993 to that in 1998?
Offer a very short reply. 1.02. What is the ratio of the Area (% of total land area) in Arable land in 1993 to that in 1998?
Provide a short and direct response. 0.99. What is the ratio of the Area (% of total land area) in Arable land in 1994 to that in 1995?
Your answer should be compact. 1. What is the ratio of the Area (% of total land area) in Terrestrial protected areas in 1994 to that in 1996?
Offer a very short reply. 0.8. What is the ratio of the Area (% of total land area) in Agricultural land in 1994 to that in 1996?
Make the answer very short. 1.01. What is the ratio of the Area (% of total land area) in Arable land in 1994 to that in 1996?
Your answer should be compact. 1. What is the ratio of the Area (% of total land area) in Terrestrial protected areas in 1994 to that in 1997?
Keep it short and to the point. 0.68. What is the ratio of the Area (% of total land area) of Agricultural land in 1994 to that in 1997?
Your response must be concise. 1.02. What is the ratio of the Area (% of total land area) in Terrestrial protected areas in 1994 to that in 1998?
Your response must be concise. 0.62. What is the ratio of the Area (% of total land area) of Agricultural land in 1994 to that in 1998?
Offer a very short reply. 1.02. What is the ratio of the Area (% of total land area) in Arable land in 1994 to that in 1998?
Keep it short and to the point. 1. What is the ratio of the Area (% of total land area) of Terrestrial protected areas in 1995 to that in 1996?
Give a very brief answer. 0.81. What is the ratio of the Area (% of total land area) of Agricultural land in 1995 to that in 1996?
Offer a very short reply. 1. What is the ratio of the Area (% of total land area) of Arable land in 1995 to that in 1996?
Make the answer very short. 1. What is the ratio of the Area (% of total land area) of Permanent crop land in 1995 to that in 1996?
Keep it short and to the point. 1. What is the ratio of the Area (% of total land area) in Terrestrial protected areas in 1995 to that in 1997?
Offer a terse response. 0.68. What is the ratio of the Area (% of total land area) of Agricultural land in 1995 to that in 1997?
Ensure brevity in your answer.  1.01. What is the ratio of the Area (% of total land area) in Arable land in 1995 to that in 1997?
Provide a short and direct response. 1. What is the ratio of the Area (% of total land area) of Permanent crop land in 1995 to that in 1997?
Provide a succinct answer. 1. What is the ratio of the Area (% of total land area) in Terrestrial protected areas in 1995 to that in 1998?
Make the answer very short. 0.63. What is the ratio of the Area (% of total land area) in Agricultural land in 1995 to that in 1998?
Keep it short and to the point. 1.01. What is the ratio of the Area (% of total land area) of Terrestrial protected areas in 1996 to that in 1997?
Your answer should be compact. 0.85. What is the ratio of the Area (% of total land area) of Agricultural land in 1996 to that in 1997?
Keep it short and to the point. 1.01. What is the ratio of the Area (% of total land area) of Arable land in 1996 to that in 1997?
Ensure brevity in your answer.  1. What is the ratio of the Area (% of total land area) in Terrestrial protected areas in 1996 to that in 1998?
Offer a very short reply. 0.78. What is the ratio of the Area (% of total land area) in Agricultural land in 1996 to that in 1998?
Your response must be concise. 1.01. What is the ratio of the Area (% of total land area) in Arable land in 1996 to that in 1998?
Your answer should be very brief. 1. What is the ratio of the Area (% of total land area) of Terrestrial protected areas in 1997 to that in 1998?
Provide a short and direct response. 0.92. What is the ratio of the Area (% of total land area) of Agricultural land in 1997 to that in 1998?
Your response must be concise. 1. What is the ratio of the Area (% of total land area) in Arable land in 1997 to that in 1998?
Ensure brevity in your answer.  0.99. What is the difference between the highest and the second highest Area (% of total land area) of Terrestrial protected areas?
Your response must be concise. 0.44. What is the difference between the highest and the second highest Area (% of total land area) of Agricultural land?
Offer a very short reply. 0.03. What is the difference between the highest and the second highest Area (% of total land area) of Arable land?
Ensure brevity in your answer.  0.03. What is the difference between the highest and the second highest Area (% of total land area) in Permanent crop land?
Offer a very short reply. 0.03. What is the difference between the highest and the lowest Area (% of total land area) of Terrestrial protected areas?
Provide a succinct answer. 2.41. What is the difference between the highest and the lowest Area (% of total land area) in Agricultural land?
Your response must be concise. 0.86. What is the difference between the highest and the lowest Area (% of total land area) in Arable land?
Give a very brief answer. 0.43. What is the difference between the highest and the lowest Area (% of total land area) of Permanent crop land?
Make the answer very short. 0.03. 